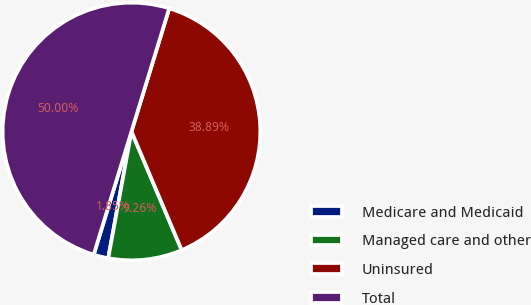<chart> <loc_0><loc_0><loc_500><loc_500><pie_chart><fcel>Medicare and Medicaid<fcel>Managed care and other<fcel>Uninsured<fcel>Total<nl><fcel>1.85%<fcel>9.26%<fcel>38.89%<fcel>50.0%<nl></chart> 